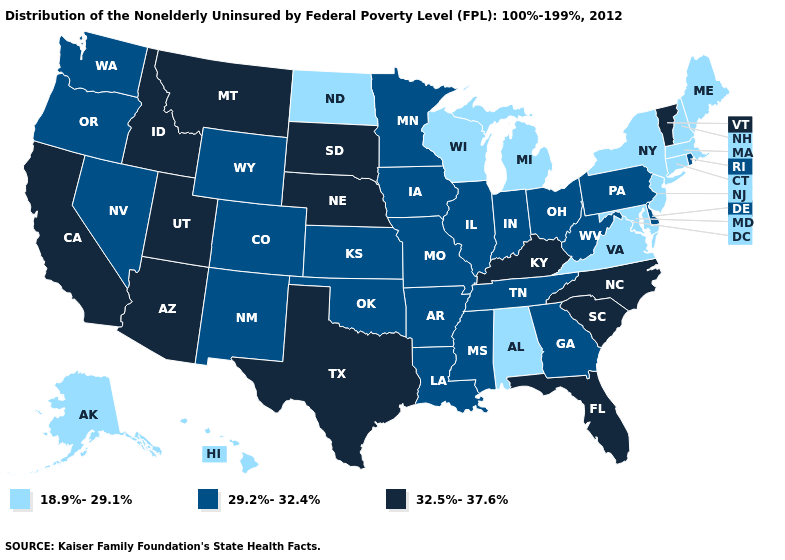Name the states that have a value in the range 32.5%-37.6%?
Short answer required. Arizona, California, Florida, Idaho, Kentucky, Montana, Nebraska, North Carolina, South Carolina, South Dakota, Texas, Utah, Vermont. Name the states that have a value in the range 32.5%-37.6%?
Give a very brief answer. Arizona, California, Florida, Idaho, Kentucky, Montana, Nebraska, North Carolina, South Carolina, South Dakota, Texas, Utah, Vermont. Name the states that have a value in the range 29.2%-32.4%?
Short answer required. Arkansas, Colorado, Delaware, Georgia, Illinois, Indiana, Iowa, Kansas, Louisiana, Minnesota, Mississippi, Missouri, Nevada, New Mexico, Ohio, Oklahoma, Oregon, Pennsylvania, Rhode Island, Tennessee, Washington, West Virginia, Wyoming. Name the states that have a value in the range 18.9%-29.1%?
Be succinct. Alabama, Alaska, Connecticut, Hawaii, Maine, Maryland, Massachusetts, Michigan, New Hampshire, New Jersey, New York, North Dakota, Virginia, Wisconsin. What is the value of Delaware?
Answer briefly. 29.2%-32.4%. Among the states that border Iowa , does Minnesota have the highest value?
Write a very short answer. No. Does the first symbol in the legend represent the smallest category?
Give a very brief answer. Yes. Name the states that have a value in the range 32.5%-37.6%?
Give a very brief answer. Arizona, California, Florida, Idaho, Kentucky, Montana, Nebraska, North Carolina, South Carolina, South Dakota, Texas, Utah, Vermont. What is the highest value in the USA?
Short answer required. 32.5%-37.6%. What is the value of Connecticut?
Quick response, please. 18.9%-29.1%. What is the value of North Dakota?
Quick response, please. 18.9%-29.1%. Does Washington have the highest value in the USA?
Concise answer only. No. Does the map have missing data?
Give a very brief answer. No. What is the lowest value in the USA?
Short answer required. 18.9%-29.1%. What is the highest value in the USA?
Concise answer only. 32.5%-37.6%. 